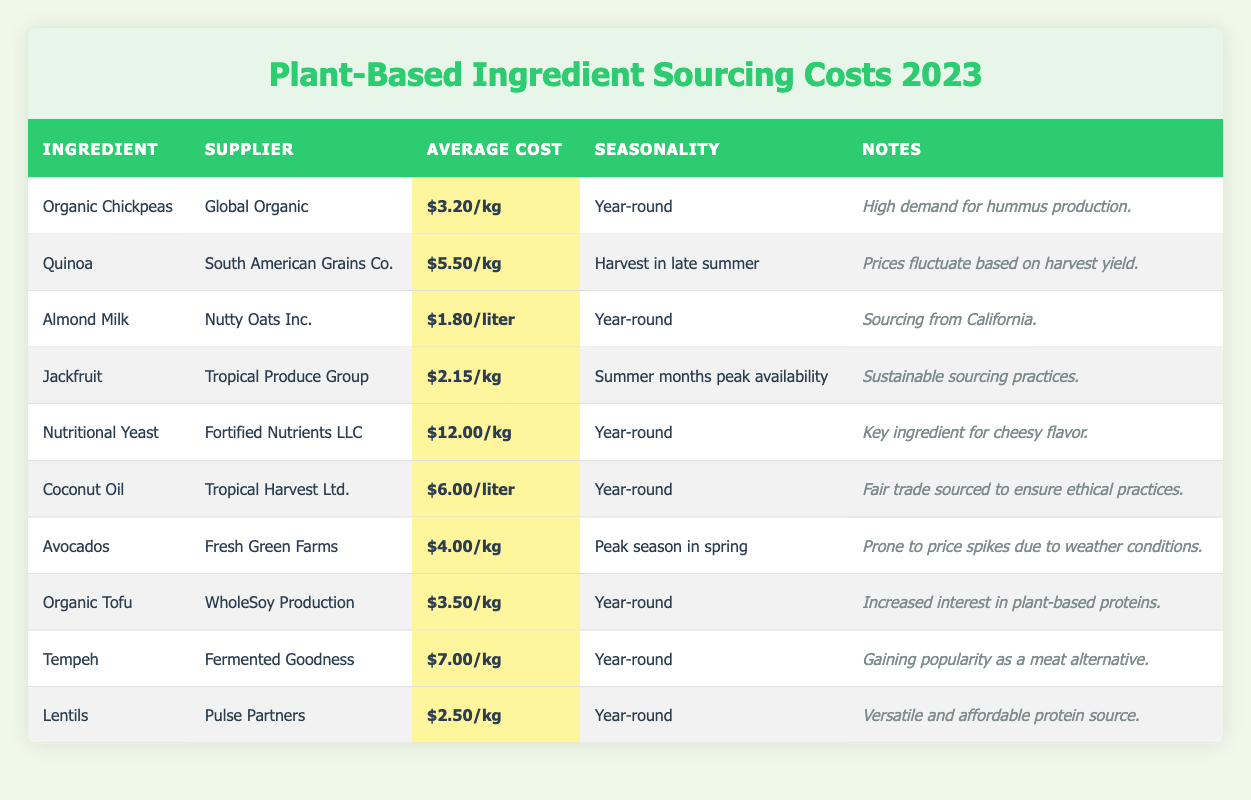What is the average cost of Organic Chickpeas per kilogram? The table shows that the average cost of Organic Chickpeas is listed as $3.20 per kilogram.
Answer: $3.20/kg Which ingredient has the highest sourcing cost? By examining the table, Nutritional Yeast has the highest average cost at $12.00 per kilogram.
Answer: Nutritional Yeast Is Jackfruit available year-round? The table indicates that Jackfruit has peak availability in the summer months, meaning it is not available year-round.
Answer: No What is the combined average cost of Coconut Oil and Avocados per liter? Coconut Oil costs $6.00 per liter, and Avocados cost $4.00 per kilogram. We need to convert the Avocado cost into liters (if relevant) or keep it separate. The combined average of Coconut Oil is $6.00 and Avocados is not directly comparable. It’s blurry without conversion, thus focusing on Coconut Oil as $6.00/liter is feasible for this query.
Answer: N/A (costs are measured differently) How much cheaper is Jackfruit compared to Tempeh? The average cost of Jackfruit is $2.15 per kilogram, while Tempeh costs $7.00 per kilogram. To find how much cheaper Jackfruit is than Tempeh, subtract the two costs: $7.00 - $2.15 = $4.85.
Answer: $4.85 Which ingredient is noted for sustainable sourcing practices? According to the table, Jackfruit is specifically mentioned for its sustainable sourcing practices.
Answer: Jackfruit How many ingredients are available year-round? The table lists a total of 6 ingredients that are available year-round: Organic Chickpeas, Almond Milk, Nutritional Yeast, Coconut Oil, Organic Tofu, and Lentils.
Answer: 6 What is the cost difference between the cheapest and most expensive ingredient? The cheapest ingredient is Jackfruit at $2.15 per kilogram and the most expensive is Nutritional Yeast at $12.00 per kilogram. The difference is calculated as: $12.00 - $2.15 = $9.85.
Answer: $9.85 During which season is Quinoa harvested? The table specifies that Quinoa is harvested in the late summer.
Answer: Late summer Is Avocados' price affected by weather conditions? Yes, the table notes that Avocados are prone to price spikes due to weather conditions.
Answer: Yes 